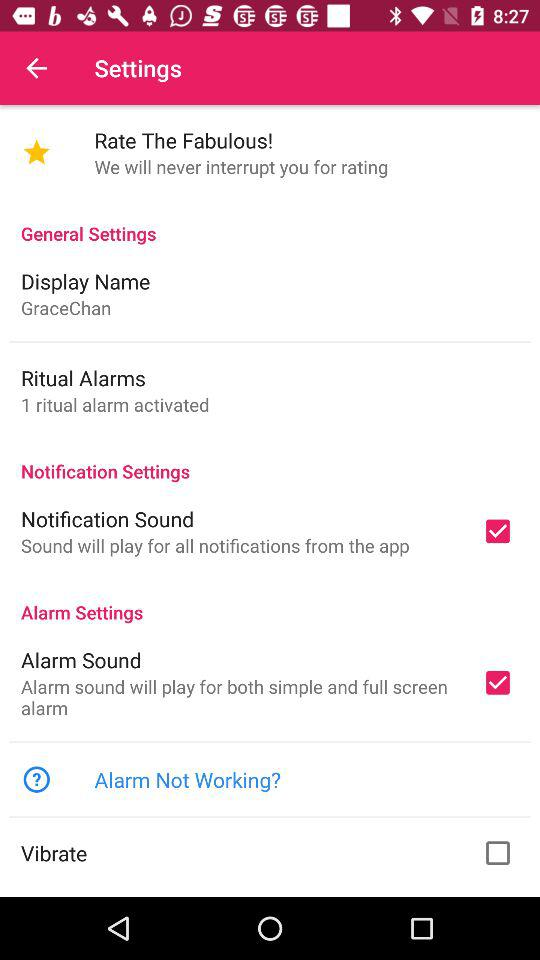How many ritual alarms are activated?
Answer the question using a single word or phrase. 1 